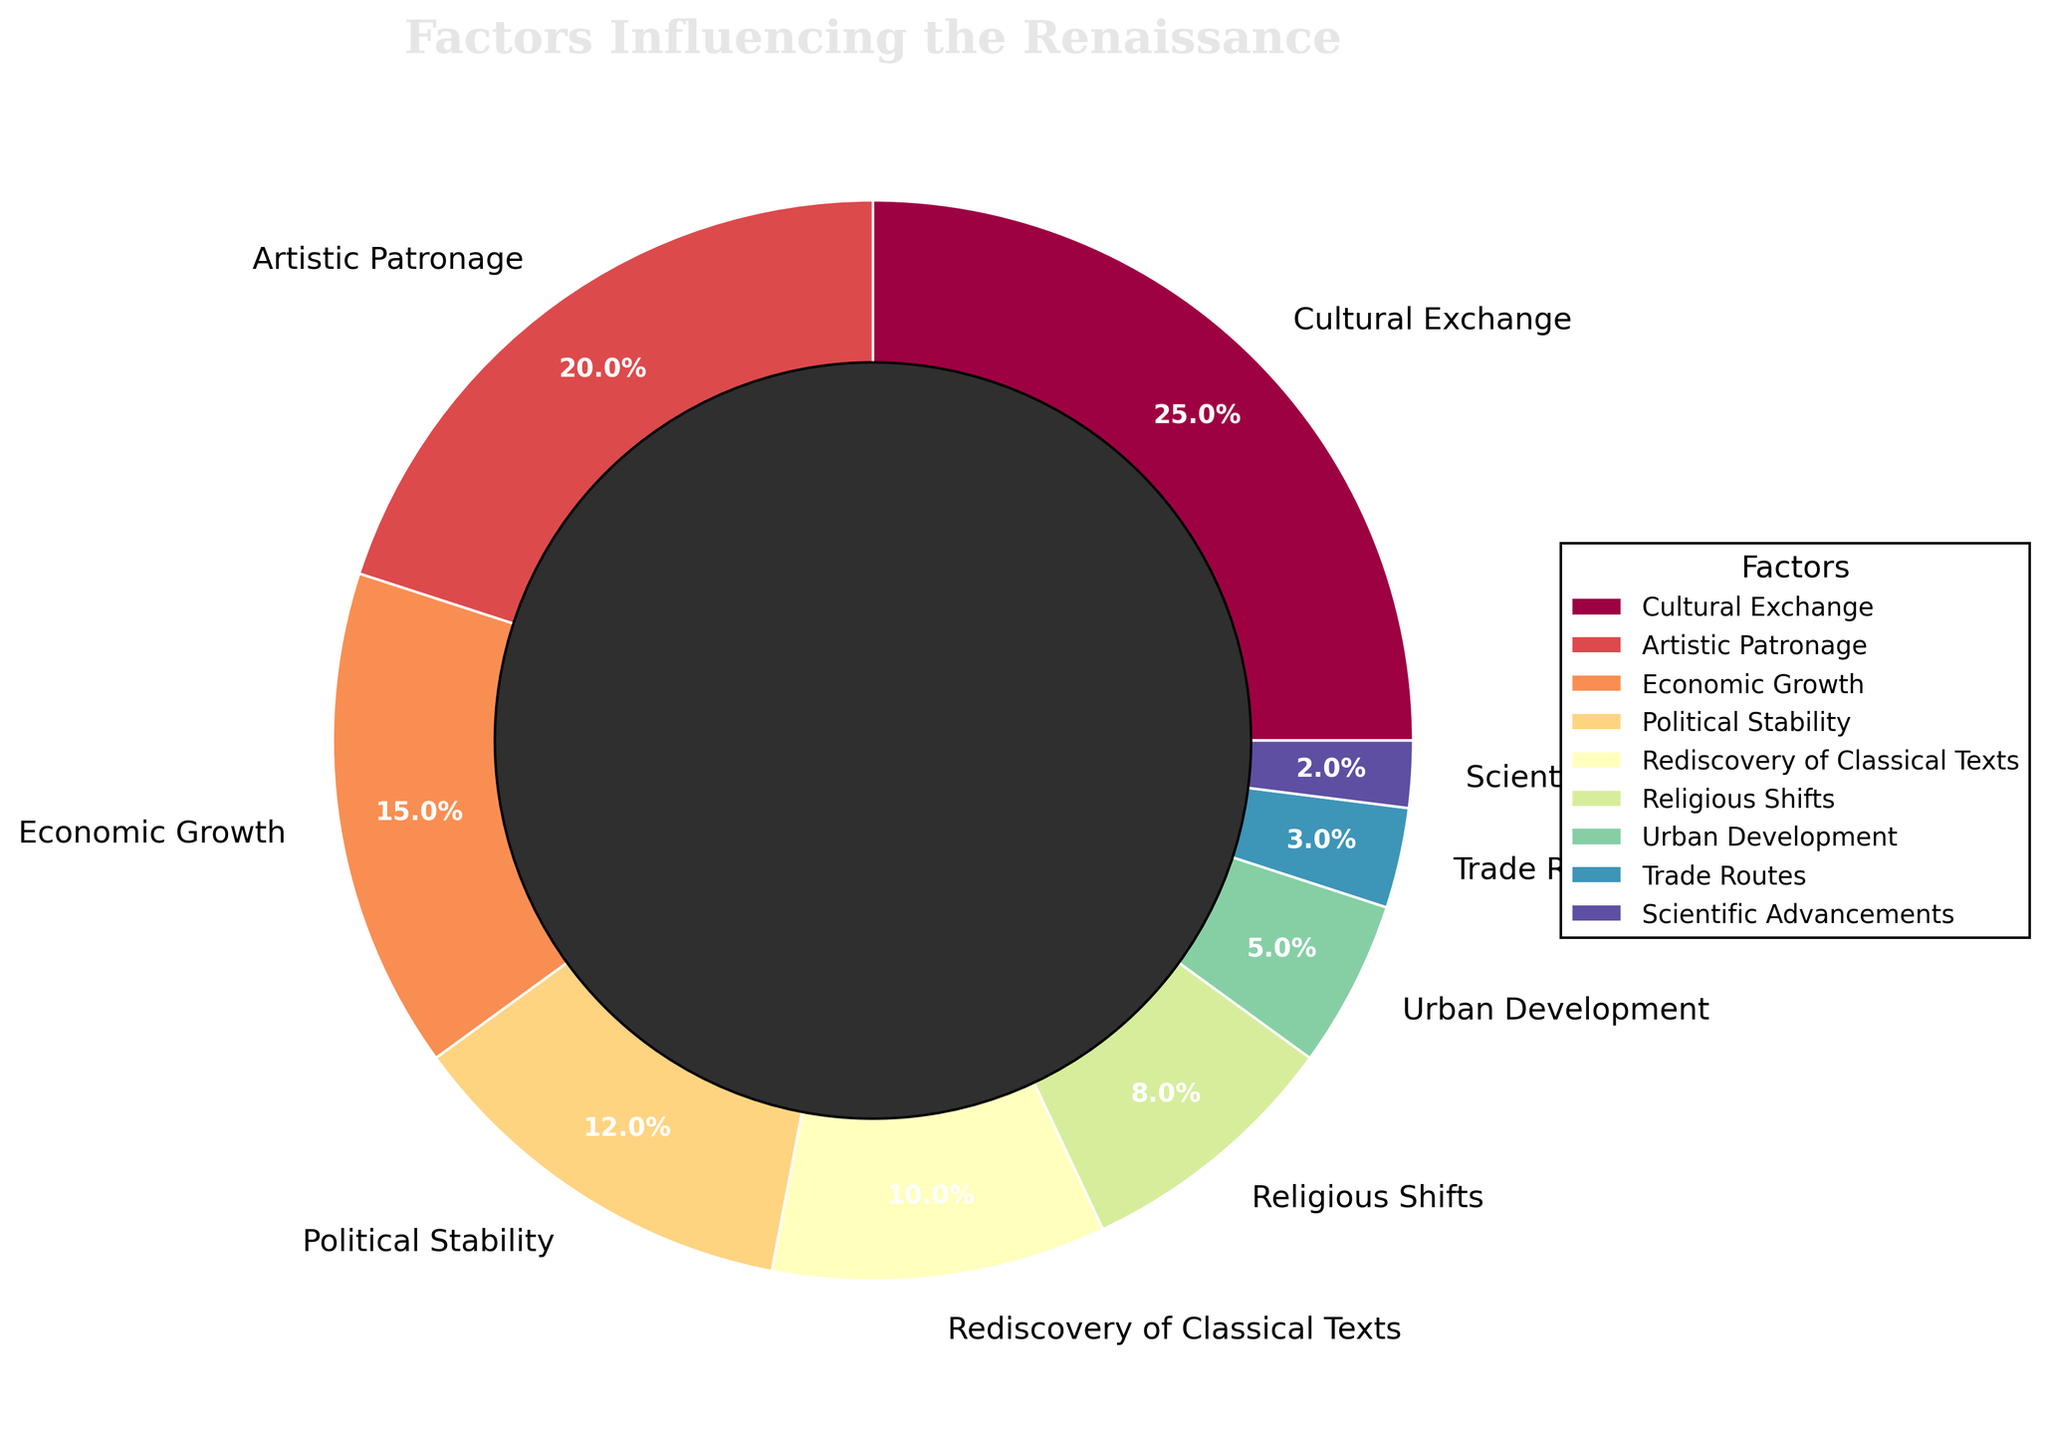What is the total percentage contribution of Cultural Exchange and Artistic Patronage? Cultural Exchange contributes 25% and Artistic Patronage contributes 20%. Adding these together gives 25% + 20% = 45%.
Answer: 45% Which factor has the smallest contribution, and what is its percentage? Scientific Advancements have the smallest contribution at 2%.
Answer: Scientific Advancements, 2% Is the sum of contributions from Political Stability and Economic Growth greater or lesser than that from Cultural Exchange? Political Stability contributes 12% and Economic Growth contributes 15%. Their sum is 12% + 15% = 27%. Cultural Exchange contributes 25%. Therefore, 27% (Political Stability + Economic Growth) is greater than 25% (Cultural Exchange).
Answer: Greater What are the two factors with the middle percentages, and what are their values? Sorting the percentages: [2, 3, 5, 8, 10, 12, 15, 20, 25], the middle values are 10% (Rediscovery of Classical Texts) and 12% (Political Stability).
Answer: Rediscovery of Classical Texts, 10% and Political Stability, 12% How much more does Cultural Exchange contribute compared to Religious Shifts? Cultural Exchange contributes 25% and Religious Shifts contributes 8%. The difference is 25% - 8% = 17%.
Answer: 17% What is the average percentage contribution of all factors combined? Adding all contributions: (25 + 20 + 15 + 12 + 10 + 8 + 5 + 3 + 2) = 100%. Dividing by the number of factors (9) gives 100 / 9 ≈ 11.1%.
Answer: 11.1% If you combine the contributions of Urban Development and Trade Routes, how does it compare to the contribution of Artistic Patronage? Urban Development contributes 5% and Trade Routes contribute 3%. Their combined contribution is 5% + 3% = 8%, which is less than the 20% contribution of Artistic Patronage.
Answer: Less Which three factors have the highest contributions, and what are their combined percentage values? The three highest contributions are from Cultural Exchange (25%), Artistic Patronage (20%), and Economic Growth (15%). Their combined contribution is 25% + 20% + 15% = 60%.
Answer: Cultural Exchange, Artistic Patronage, Economic Growth; 60% Which factor uses the color at the center of the color spectrum in the chart? The color spectrum ranges from start to end through various hues. At the center of the spectrum (middle index), given there are 9 factors, would correspond to the 5th factor in the sequence. The 5th factor is Rediscovery of Classical Texts.
Answer: Rediscovery of Classical Texts 